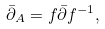Convert formula to latex. <formula><loc_0><loc_0><loc_500><loc_500>\bar { \partial } _ { A } = f \bar { \partial } f ^ { - 1 } ,</formula> 